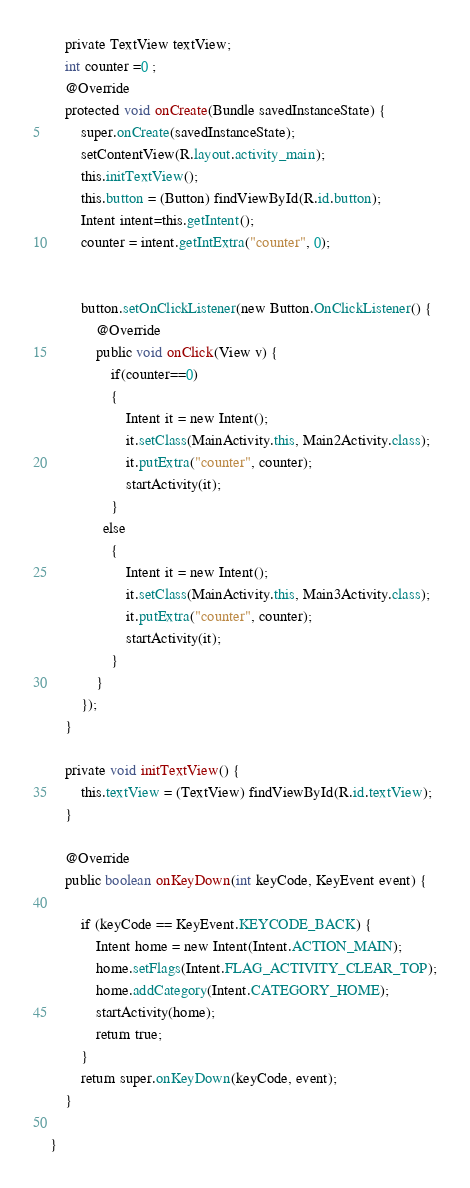Convert code to text. <code><loc_0><loc_0><loc_500><loc_500><_Java_>    private TextView textView;
    int counter =0 ;
    @Override
    protected void onCreate(Bundle savedInstanceState) {
        super.onCreate(savedInstanceState);
        setContentView(R.layout.activity_main);
        this.initTextView();
        this.button = (Button) findViewById(R.id.button);
        Intent intent=this.getIntent();
        counter = intent.getIntExtra("counter", 0);


        button.setOnClickListener(new Button.OnClickListener() {
            @Override
            public void onClick(View v) {
                if(counter==0)
                {
                    Intent it = new Intent();
                    it.setClass(MainActivity.this, Main2Activity.class);
                    it.putExtra("counter", counter);
                    startActivity(it);
                }
              else
                {
                    Intent it = new Intent();
                    it.setClass(MainActivity.this, Main3Activity.class);
                    it.putExtra("counter", counter);
                    startActivity(it);
                }
            }
        });
    }

    private void initTextView() {
        this.textView = (TextView) findViewById(R.id.textView);
    }

    @Override
    public boolean onKeyDown(int keyCode, KeyEvent event) {

        if (keyCode == KeyEvent.KEYCODE_BACK) {
            Intent home = new Intent(Intent.ACTION_MAIN);
            home.setFlags(Intent.FLAG_ACTIVITY_CLEAR_TOP);
            home.addCategory(Intent.CATEGORY_HOME);
            startActivity(home);
            return true;
        }
        return super.onKeyDown(keyCode, event);
    }

}
</code> 